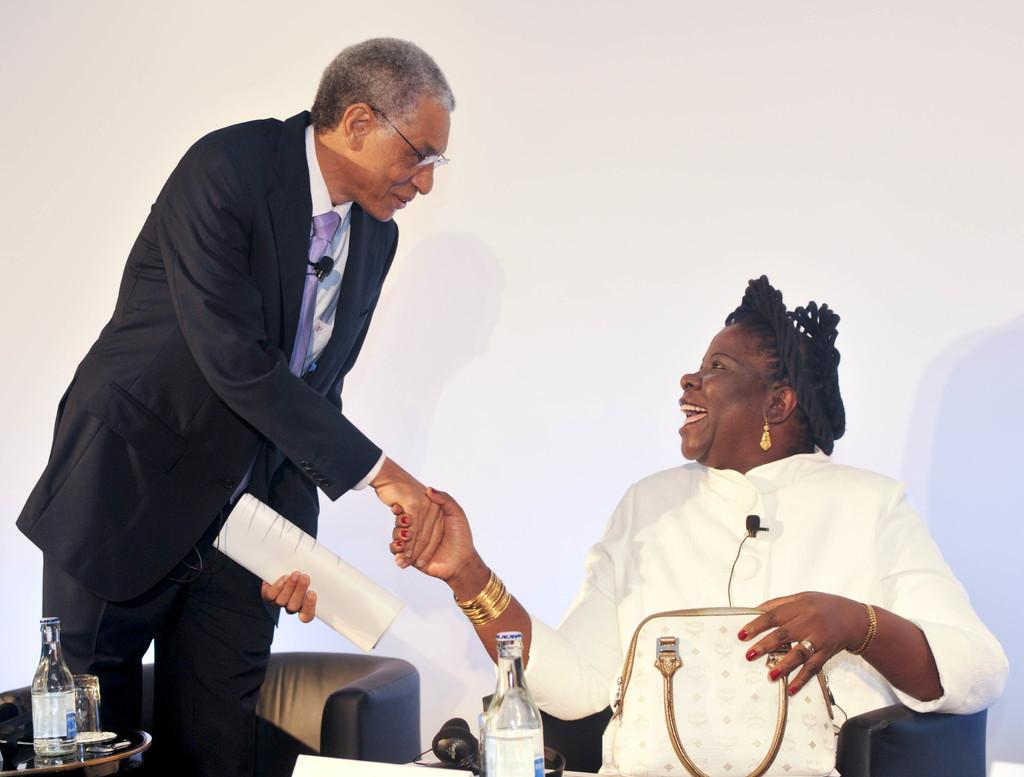What is the woman doing in the image? The woman is sitting on a chair in the image. What is on the table in the image? There is a bottle and headphones on the table in the image. What is the man holding in the image? The man is holding a paper in the image. Can you describe the man's position in the image? The man is standing in the image. What type of wren can be seen perched on the structure in the image? There is no wren or structure present in the image. 